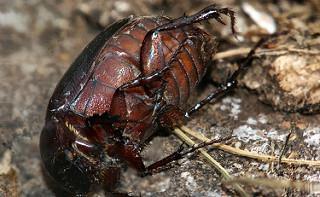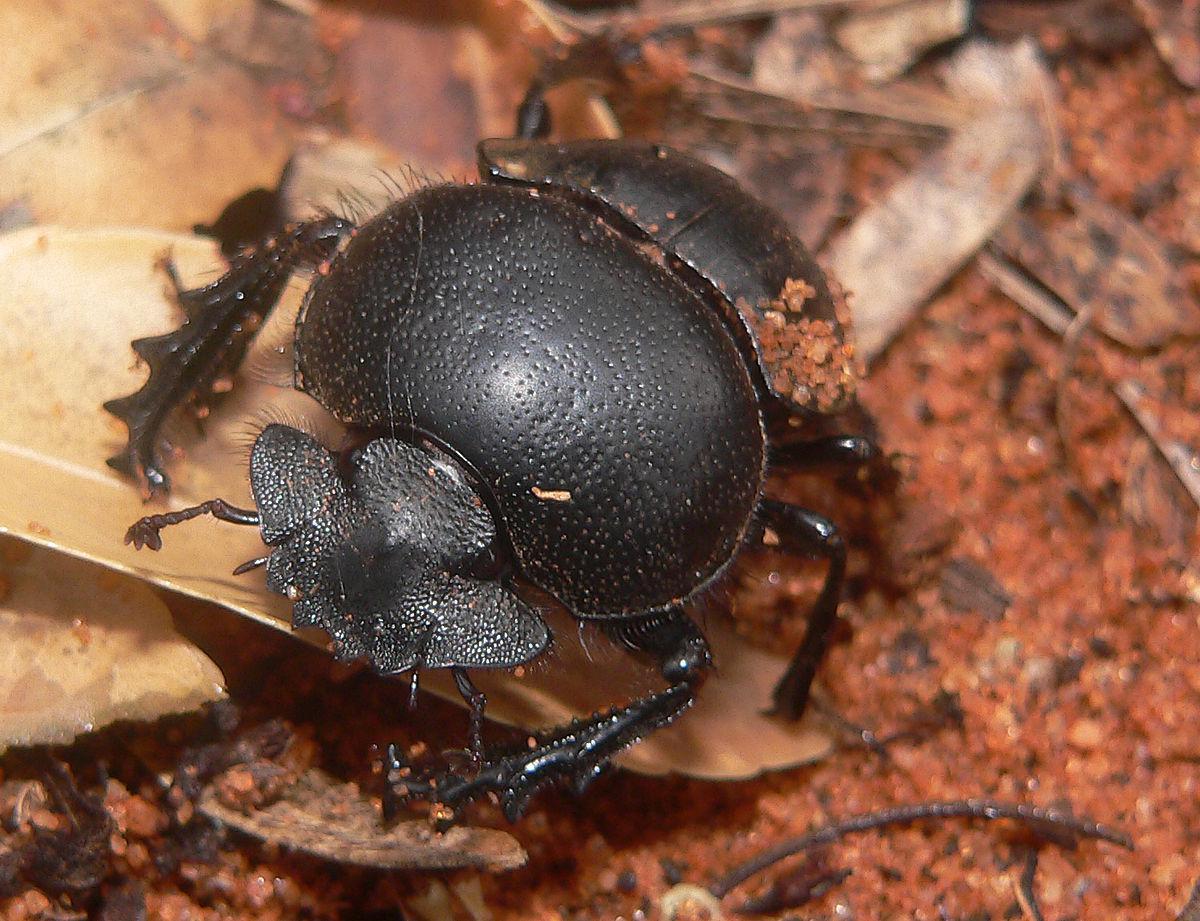The first image is the image on the left, the second image is the image on the right. Examine the images to the left and right. Is the description "One image shows the underside of a beetle instead of the top side." accurate? Answer yes or no. Yes. The first image is the image on the left, the second image is the image on the right. Given the left and right images, does the statement "The beetle on the left is near green grass." hold true? Answer yes or no. No. 